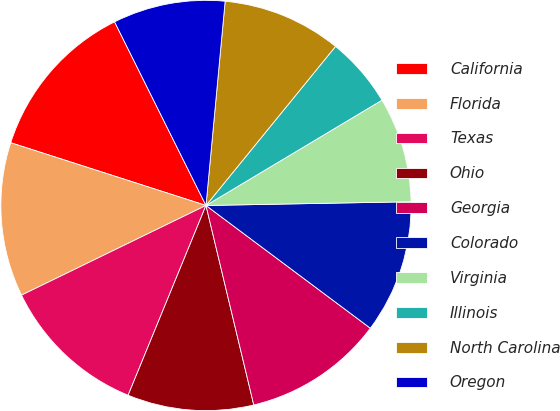Convert chart. <chart><loc_0><loc_0><loc_500><loc_500><pie_chart><fcel>California<fcel>Florida<fcel>Texas<fcel>Ohio<fcel>Georgia<fcel>Colorado<fcel>Virginia<fcel>Illinois<fcel>North Carolina<fcel>Oregon<nl><fcel>12.7%<fcel>12.15%<fcel>11.6%<fcel>9.94%<fcel>11.05%<fcel>10.5%<fcel>8.29%<fcel>5.54%<fcel>9.39%<fcel>8.84%<nl></chart> 